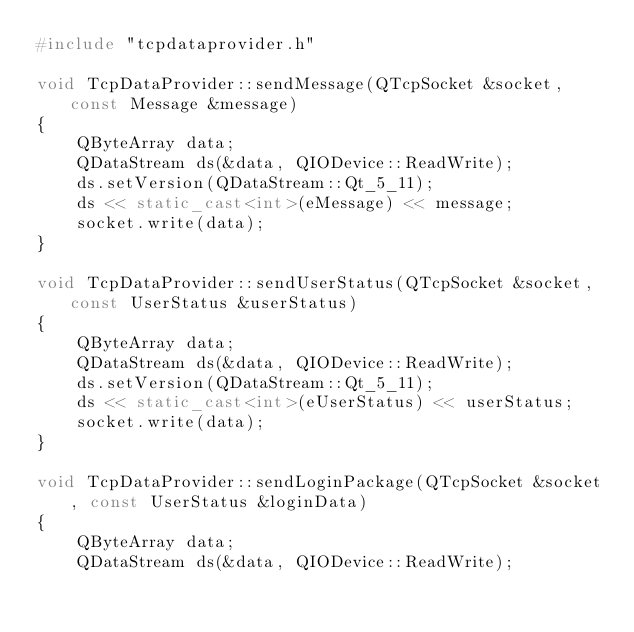<code> <loc_0><loc_0><loc_500><loc_500><_C++_>#include "tcpdataprovider.h"

void TcpDataProvider::sendMessage(QTcpSocket &socket, const Message &message)
{
    QByteArray data;
    QDataStream ds(&data, QIODevice::ReadWrite);
    ds.setVersion(QDataStream::Qt_5_11);
    ds << static_cast<int>(eMessage) << message;
    socket.write(data);
}

void TcpDataProvider::sendUserStatus(QTcpSocket &socket, const UserStatus &userStatus)
{
    QByteArray data;
    QDataStream ds(&data, QIODevice::ReadWrite);
    ds.setVersion(QDataStream::Qt_5_11);
    ds << static_cast<int>(eUserStatus) << userStatus;
    socket.write(data);
}

void TcpDataProvider::sendLoginPackage(QTcpSocket &socket, const UserStatus &loginData)
{
    QByteArray data;
    QDataStream ds(&data, QIODevice::ReadWrite);</code> 